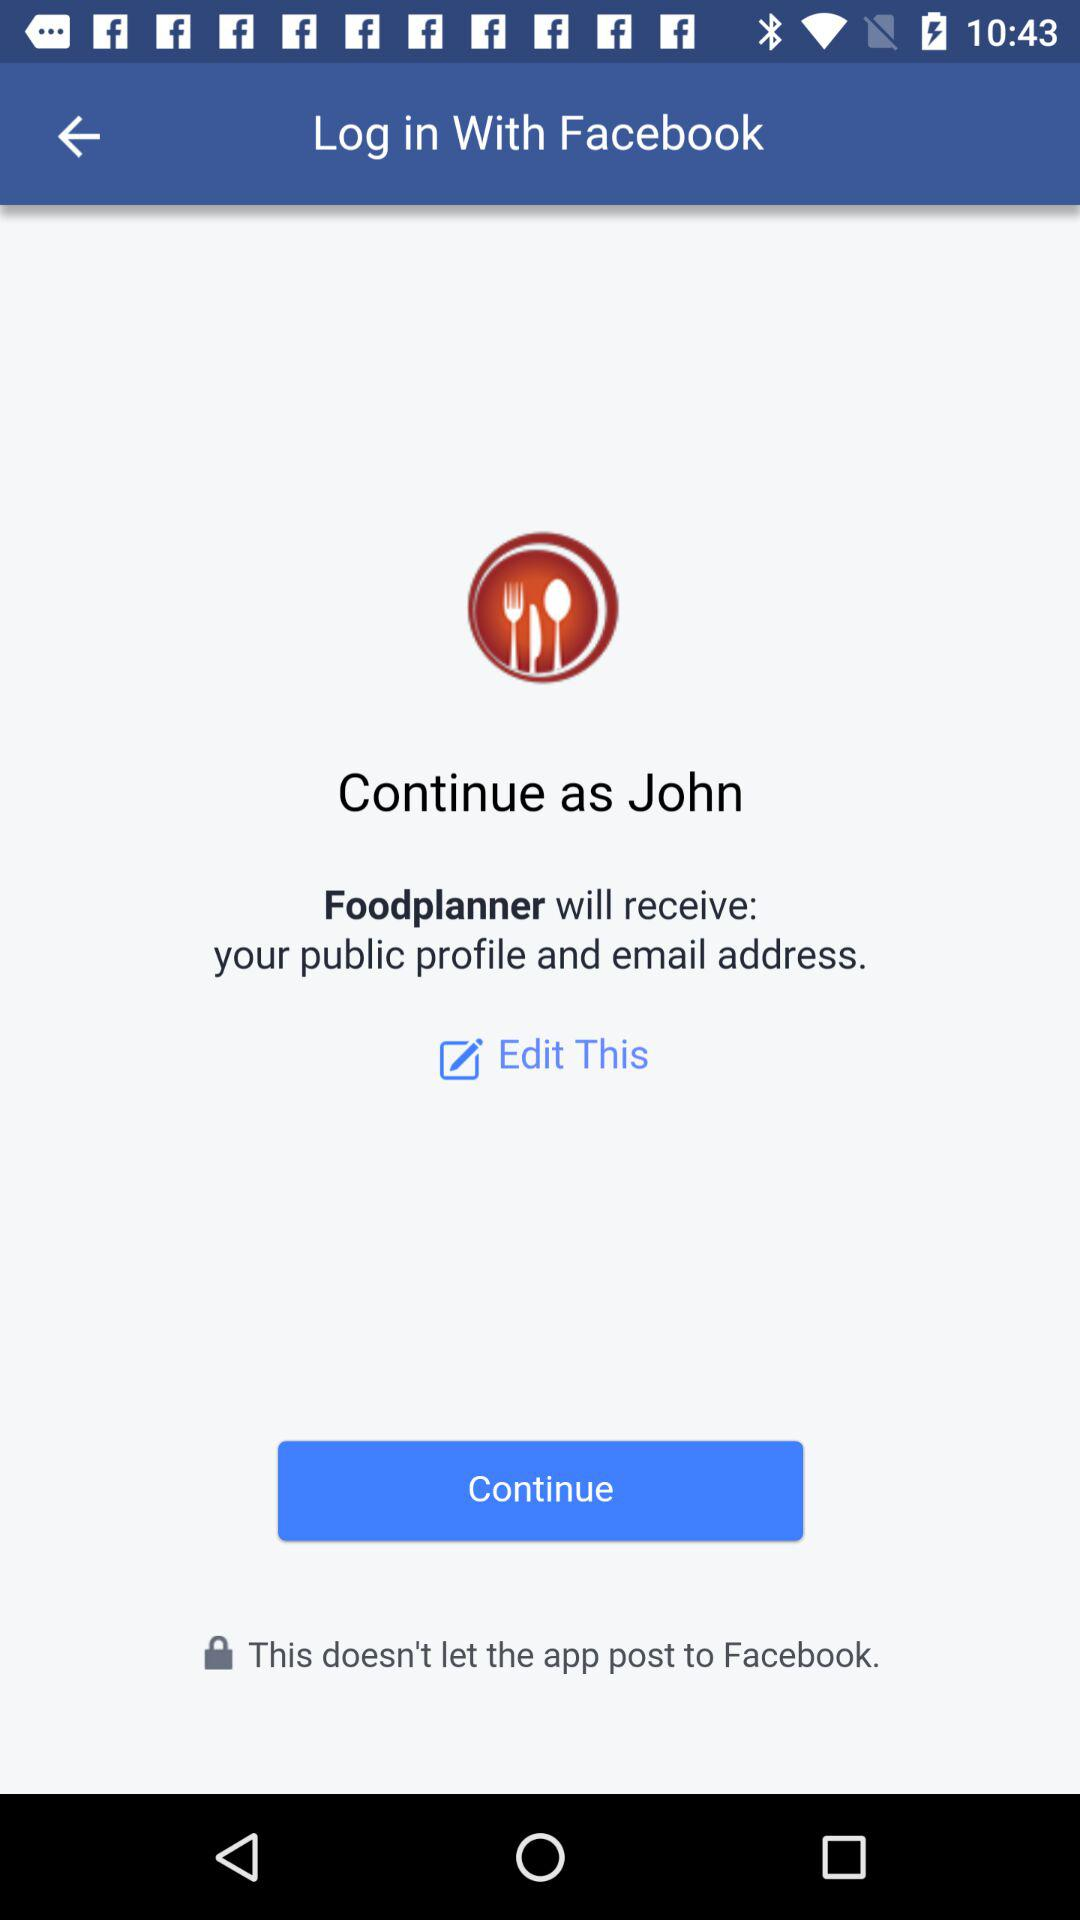What is the user name? The user name is John. 